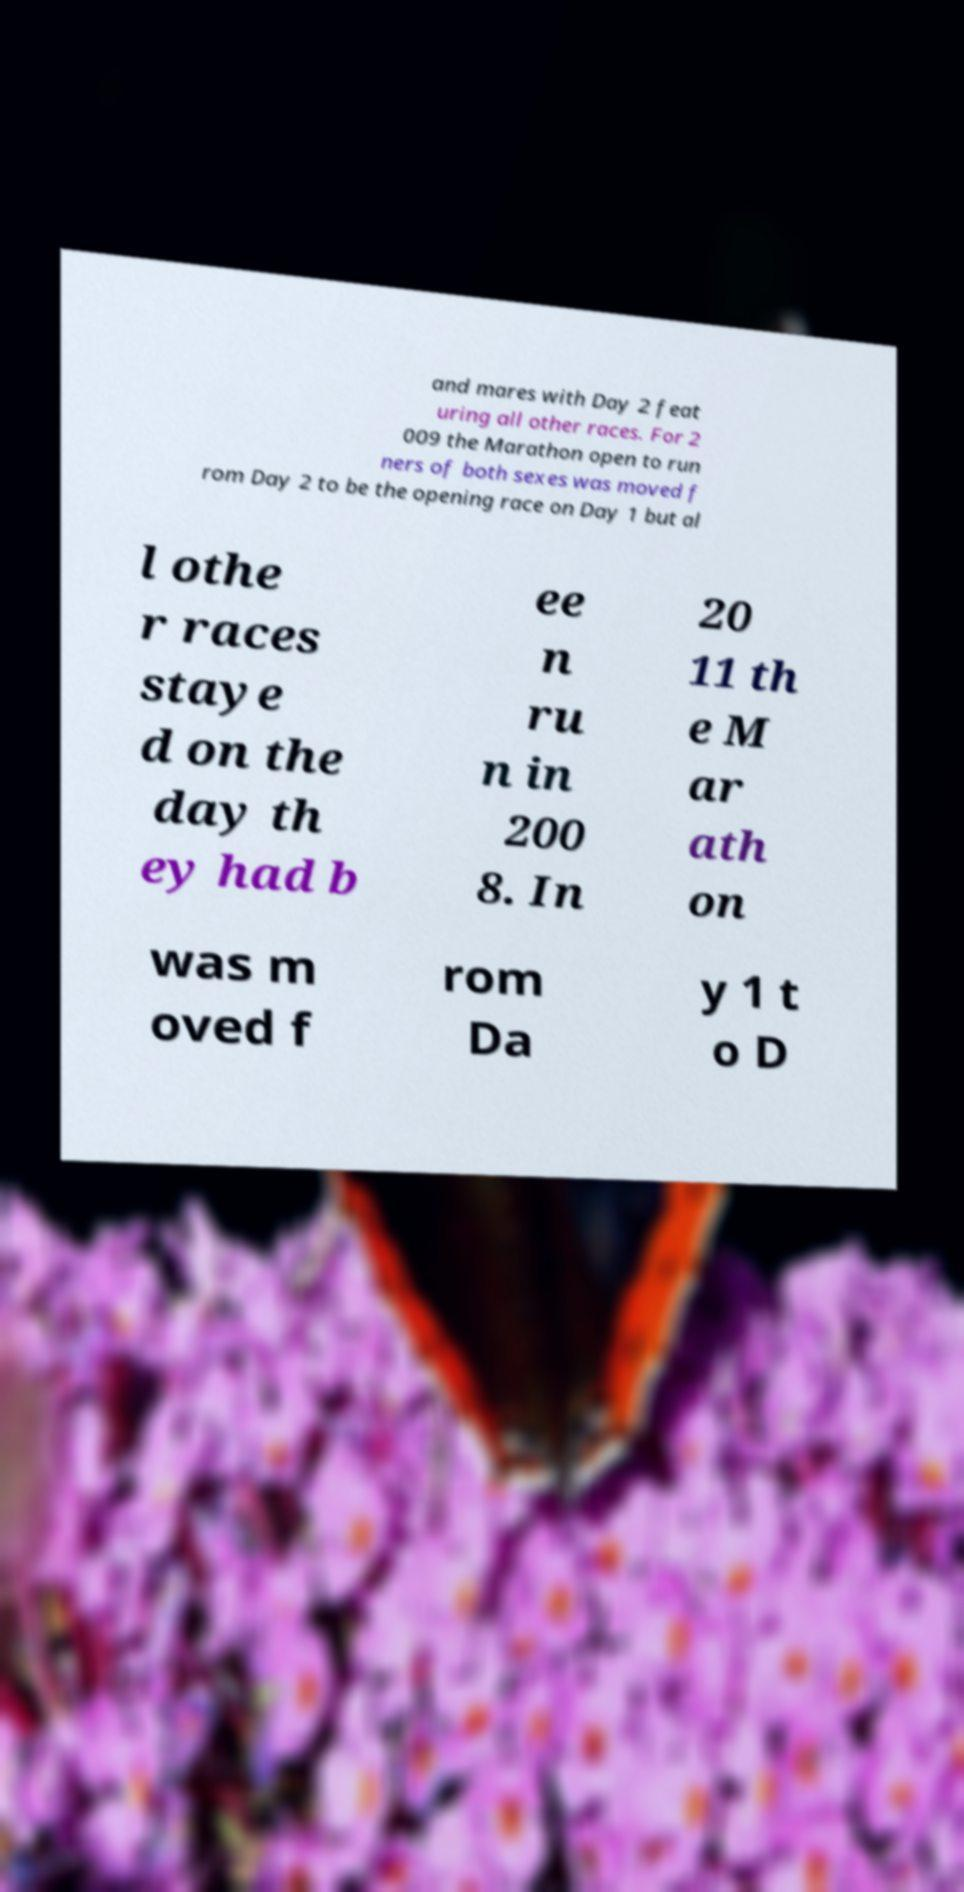What messages or text are displayed in this image? I need them in a readable, typed format. and mares with Day 2 feat uring all other races. For 2 009 the Marathon open to run ners of both sexes was moved f rom Day 2 to be the opening race on Day 1 but al l othe r races staye d on the day th ey had b ee n ru n in 200 8. In 20 11 th e M ar ath on was m oved f rom Da y 1 t o D 